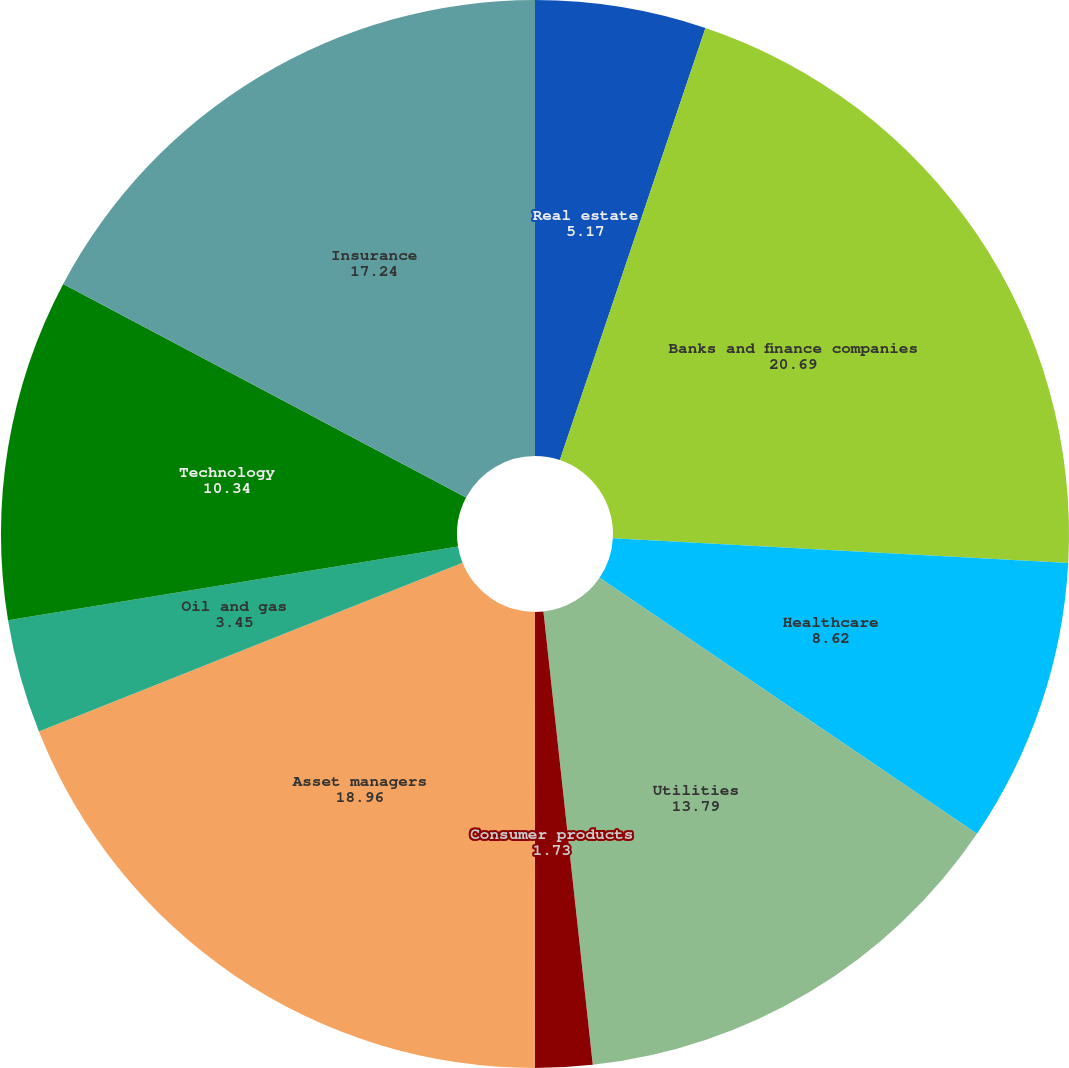Convert chart to OTSL. <chart><loc_0><loc_0><loc_500><loc_500><pie_chart><fcel>Real estate<fcel>Banks and finance companies<fcel>Healthcare<fcel>Utilities<fcel>Consumer products<fcel>Asset managers<fcel>Oil and gas<fcel>Technology<fcel>Insurance<fcel>Machinery and equipment<nl><fcel>5.17%<fcel>20.69%<fcel>8.62%<fcel>13.79%<fcel>1.73%<fcel>18.96%<fcel>3.45%<fcel>10.34%<fcel>17.24%<fcel>0.0%<nl></chart> 